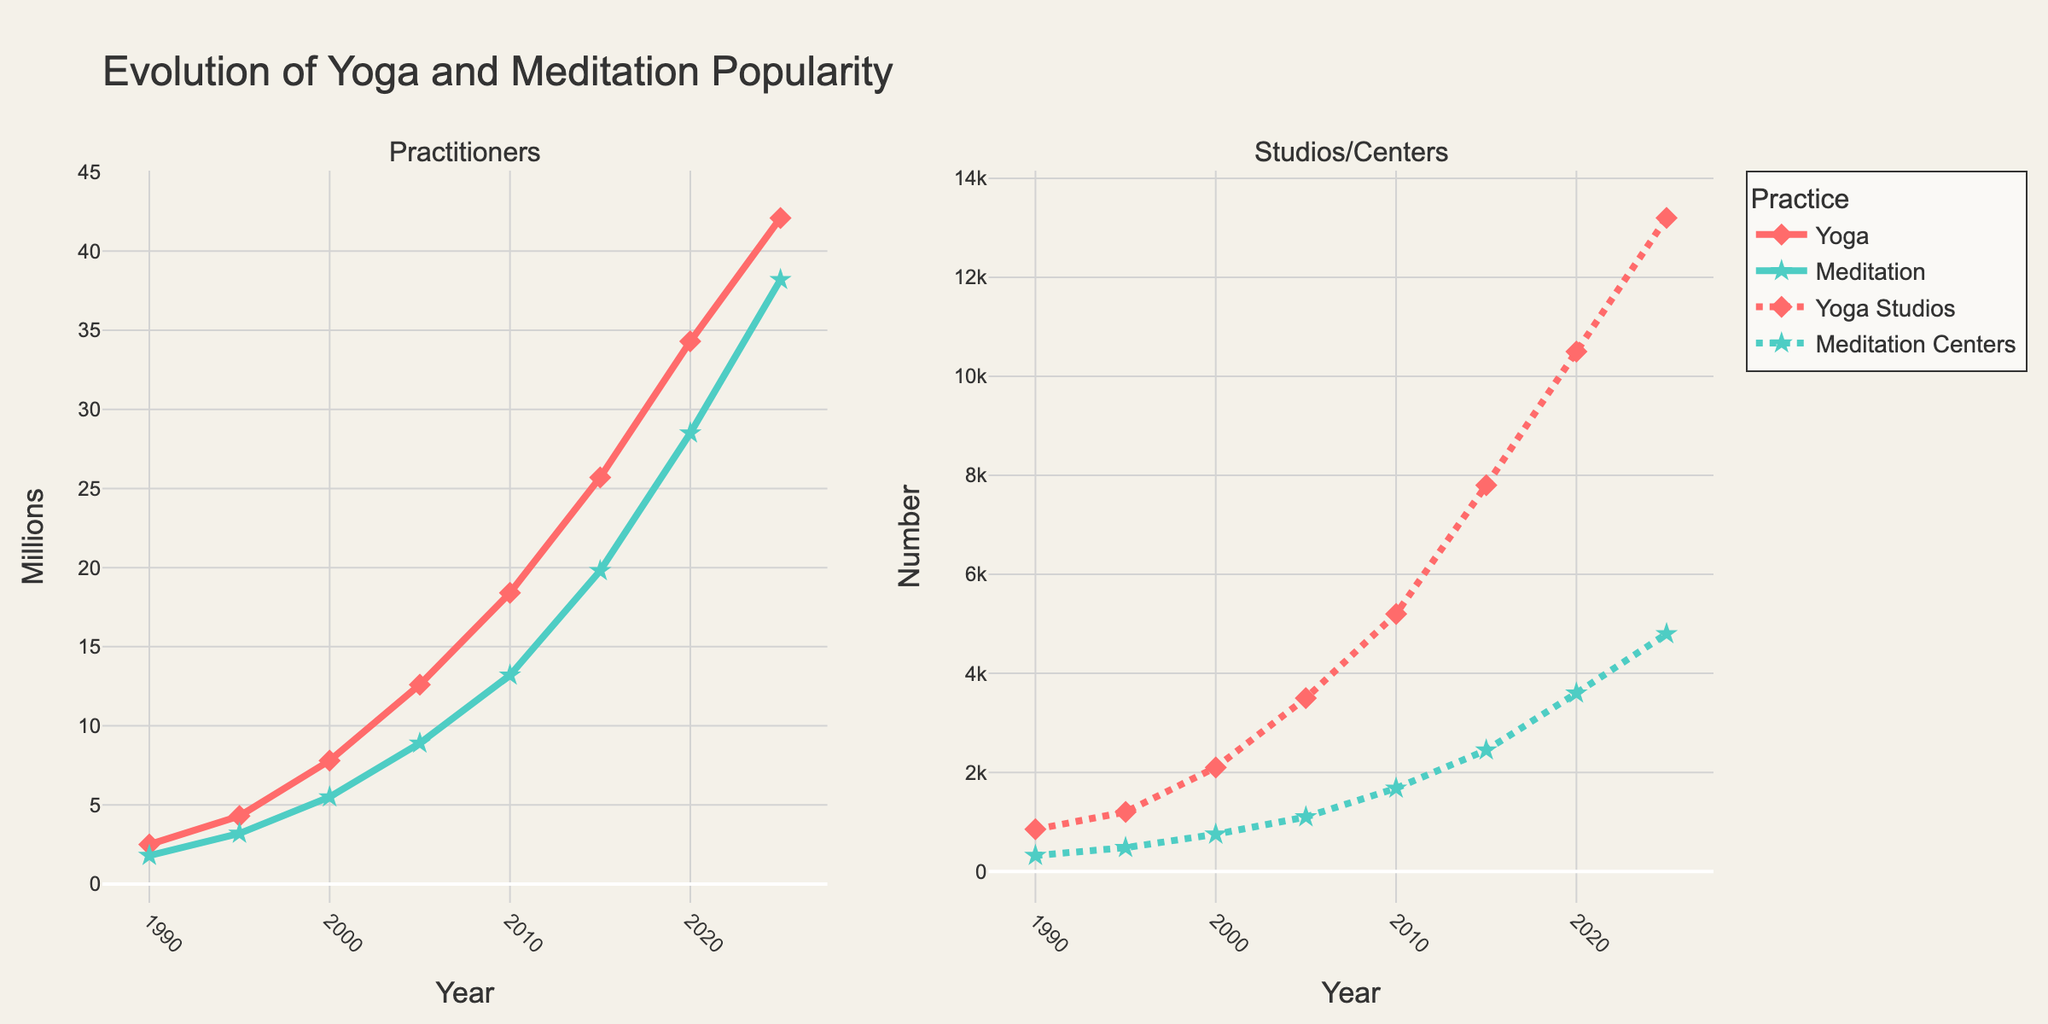What is the percentage increase in yoga practitioners from 1990 to 2020? First, find the number of yoga practitioners in 1990 (2.5 million) and 2020 (34.3 million). Then, calculate the difference (34.3 - 2.5 = 31.8). Finally, divide the difference by the 1990 value and multiply by 100 to get the percentage: (31.8 / 2.5) * 100 ≈ 1272%.
Answer: 1272% Which year saw the highest number of yoga studios? Look at the 'Yoga Studios' values and identify the highest, which is 13200 in 2025.
Answer: 2025 By how much did the number of meditation practitioners increase from 2010 to 2025? Subtract the number of meditation practitioners in 2010 (13.2 million) from the number in 2025 (38.2 million): 38.2 - 13.2 = 25 million.
Answer: 25 million Compare the growth rates between yoga practitioners and meditation practitioners from 1990 to 2020. Which one grew faster? Calculate the growth rate for each practice. Yoga: (34.3 - 2.5) / 2.5 ≈ 1272%, Meditation: (28.5 - 1.8) / 1.8 ≈ 1483%. Meditation practitioners grew faster.
Answer: Meditation practitioners How did the number of yoga studios compare to meditation centers in 2005? From the figure, the number of yoga studios in 2005 is 3500 and meditation centers are 1100. Yoga studios are more.
Answer: Yoga studios are more What's the trend in the number of yoga practitioners from 1990 to 2025? The number of yoga practitioners progressively increases each year, indicating a rising trend in popularity from 2.5 million in 1990 to 42.1 million in 2025.
Answer: Increasing trend What was the average number of yoga practitioners over the years shown? Sum the yoga practitioners for each year and divide by the number of years: (2.5 + 4.3 + 7.8 + 12.6 + 18.4 + 25.7 + 34.3 + 42.1) / 8 ≈ 18.47 million.
Answer: 18.47 million In which year did meditation centers surpass 2000? Check the 'Meditation Centers' values and see that they surpass 2000 in 2015 with 2450 centers.
Answer: 2015 Which has a greater number of locations in 2020: Yoga studios or meditation centers? From the data, yoga studios in 2020 are 10500 and meditation centers are 3600. Yoga studios have a greater number.
Answer: Yoga studios How do the growth patterns of yoga practitioners and yoga studios compare over the years? Both yoga practitioners and yoga studios show a steadily increasing pattern, with practitioners growing from 2.5 million in 1990 to 42.1 million in 2025, and studios growing from 850 in 1990 to 13200 in 2025, suggesting synchronized growth.
Answer: Synchronized growth 